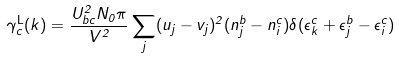<formula> <loc_0><loc_0><loc_500><loc_500>\gamma ^ { \mathrm L } _ { c } ( k ) = \frac { U _ { b c } ^ { 2 } N _ { 0 } \pi } { V ^ { 2 } } \sum _ { j } ( u _ { j } - v _ { j } ) ^ { 2 } ( n ^ { b } _ { j } - n ^ { c } _ { i } ) \delta ( \epsilon ^ { c } _ { k } + \epsilon ^ { b } _ { j } - \epsilon ^ { c } _ { i } )</formula> 